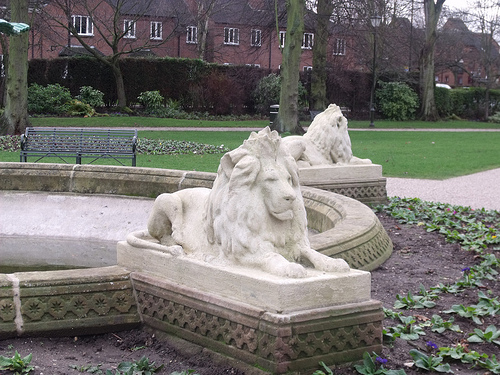<image>
Is the lion under the house? No. The lion is not positioned under the house. The vertical relationship between these objects is different. Is the lion next to the fountain? Yes. The lion is positioned adjacent to the fountain, located nearby in the same general area. 